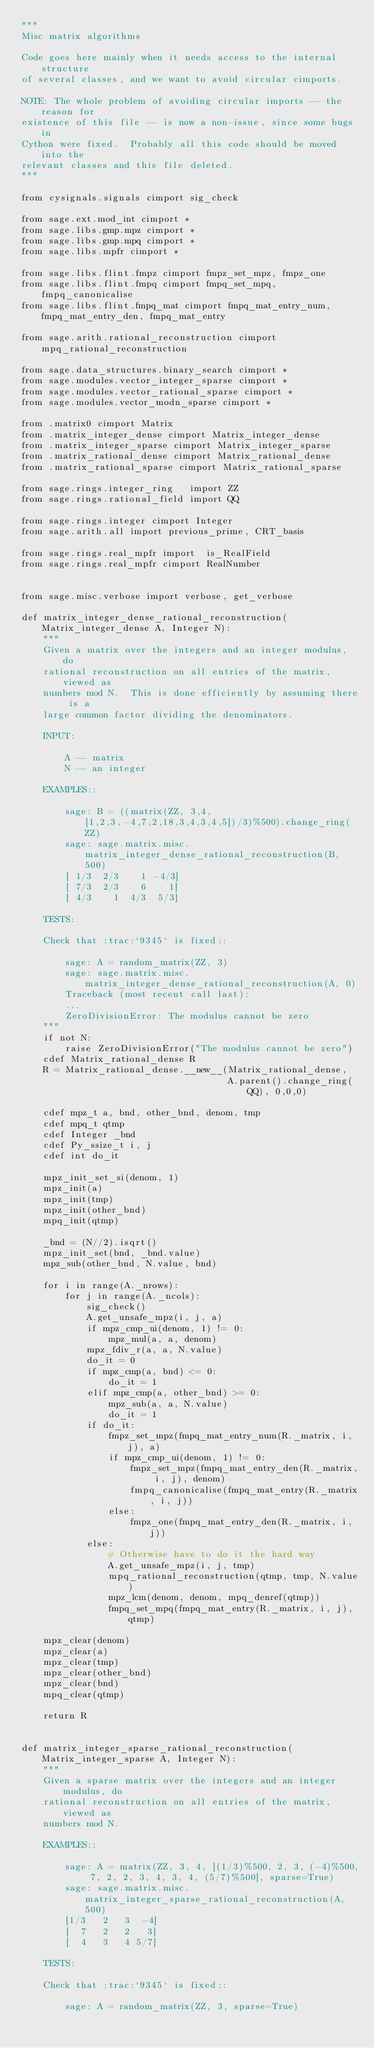Convert code to text. <code><loc_0><loc_0><loc_500><loc_500><_Cython_>"""
Misc matrix algorithms

Code goes here mainly when it needs access to the internal structure
of several classes, and we want to avoid circular cimports.

NOTE: The whole problem of avoiding circular imports -- the reason for
existence of this file -- is now a non-issue, since some bugs in
Cython were fixed.  Probably all this code should be moved into the
relevant classes and this file deleted.
"""

from cysignals.signals cimport sig_check

from sage.ext.mod_int cimport *
from sage.libs.gmp.mpz cimport *
from sage.libs.gmp.mpq cimport *
from sage.libs.mpfr cimport *

from sage.libs.flint.fmpz cimport fmpz_set_mpz, fmpz_one
from sage.libs.flint.fmpq cimport fmpq_set_mpq, fmpq_canonicalise
from sage.libs.flint.fmpq_mat cimport fmpq_mat_entry_num, fmpq_mat_entry_den, fmpq_mat_entry

from sage.arith.rational_reconstruction cimport mpq_rational_reconstruction

from sage.data_structures.binary_search cimport *
from sage.modules.vector_integer_sparse cimport *
from sage.modules.vector_rational_sparse cimport *
from sage.modules.vector_modn_sparse cimport *

from .matrix0 cimport Matrix
from .matrix_integer_dense cimport Matrix_integer_dense
from .matrix_integer_sparse cimport Matrix_integer_sparse
from .matrix_rational_dense cimport Matrix_rational_dense
from .matrix_rational_sparse cimport Matrix_rational_sparse

from sage.rings.integer_ring   import ZZ
from sage.rings.rational_field import QQ

from sage.rings.integer cimport Integer
from sage.arith.all import previous_prime, CRT_basis

from sage.rings.real_mpfr import  is_RealField
from sage.rings.real_mpfr cimport RealNumber


from sage.misc.verbose import verbose, get_verbose

def matrix_integer_dense_rational_reconstruction(Matrix_integer_dense A, Integer N):
    """
    Given a matrix over the integers and an integer modulus, do
    rational reconstruction on all entries of the matrix, viewed as
    numbers mod N.  This is done efficiently by assuming there is a
    large common factor dividing the denominators.

    INPUT:

        A -- matrix
        N -- an integer

    EXAMPLES::

        sage: B = ((matrix(ZZ, 3,4, [1,2,3,-4,7,2,18,3,4,3,4,5])/3)%500).change_ring(ZZ)
        sage: sage.matrix.misc.matrix_integer_dense_rational_reconstruction(B, 500)
        [ 1/3  2/3    1 -4/3]
        [ 7/3  2/3    6    1]
        [ 4/3    1  4/3  5/3]

    TESTS:

    Check that :trac:`9345` is fixed::

        sage: A = random_matrix(ZZ, 3)
        sage: sage.matrix.misc.matrix_integer_dense_rational_reconstruction(A, 0)
        Traceback (most recent call last):
        ...
        ZeroDivisionError: The modulus cannot be zero
    """
    if not N:
        raise ZeroDivisionError("The modulus cannot be zero")
    cdef Matrix_rational_dense R
    R = Matrix_rational_dense.__new__(Matrix_rational_dense,
                                      A.parent().change_ring(QQ), 0,0,0)

    cdef mpz_t a, bnd, other_bnd, denom, tmp
    cdef mpq_t qtmp
    cdef Integer _bnd
    cdef Py_ssize_t i, j
    cdef int do_it

    mpz_init_set_si(denom, 1)
    mpz_init(a)
    mpz_init(tmp)
    mpz_init(other_bnd)
    mpq_init(qtmp)

    _bnd = (N//2).isqrt()
    mpz_init_set(bnd, _bnd.value)
    mpz_sub(other_bnd, N.value, bnd)

    for i in range(A._nrows):
        for j in range(A._ncols):
            sig_check()
            A.get_unsafe_mpz(i, j, a)
            if mpz_cmp_ui(denom, 1) != 0:
                mpz_mul(a, a, denom)
            mpz_fdiv_r(a, a, N.value)
            do_it = 0
            if mpz_cmp(a, bnd) <= 0:
                do_it = 1
            elif mpz_cmp(a, other_bnd) >= 0:
                mpz_sub(a, a, N.value)
                do_it = 1
            if do_it:
                fmpz_set_mpz(fmpq_mat_entry_num(R._matrix, i, j), a)
                if mpz_cmp_ui(denom, 1) != 0:
                    fmpz_set_mpz(fmpq_mat_entry_den(R._matrix, i, j), denom)
                    fmpq_canonicalise(fmpq_mat_entry(R._matrix, i, j))
                else:
                    fmpz_one(fmpq_mat_entry_den(R._matrix, i, j))
            else:
                # Otherwise have to do it the hard way
                A.get_unsafe_mpz(i, j, tmp)
                mpq_rational_reconstruction(qtmp, tmp, N.value)
                mpz_lcm(denom, denom, mpq_denref(qtmp))
                fmpq_set_mpq(fmpq_mat_entry(R._matrix, i, j), qtmp)

    mpz_clear(denom)
    mpz_clear(a)
    mpz_clear(tmp)
    mpz_clear(other_bnd)
    mpz_clear(bnd)
    mpq_clear(qtmp)

    return R


def matrix_integer_sparse_rational_reconstruction(Matrix_integer_sparse A, Integer N):
    """
    Given a sparse matrix over the integers and an integer modulus, do
    rational reconstruction on all entries of the matrix, viewed as
    numbers mod N.

    EXAMPLES::

        sage: A = matrix(ZZ, 3, 4, [(1/3)%500, 2, 3, (-4)%500, 7, 2, 2, 3, 4, 3, 4, (5/7)%500], sparse=True)
        sage: sage.matrix.misc.matrix_integer_sparse_rational_reconstruction(A, 500)
        [1/3   2   3  -4]
        [  7   2   2   3]
        [  4   3   4 5/7]

    TESTS:

    Check that :trac:`9345` is fixed::

        sage: A = random_matrix(ZZ, 3, sparse=True)</code> 